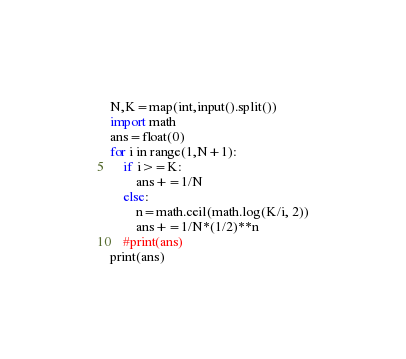Convert code to text. <code><loc_0><loc_0><loc_500><loc_500><_Python_>N,K=map(int,input().split())
import math
ans=float(0)
for i in range(1,N+1):
    if i>=K:
        ans+=1/N
    else:
        n=math.ceil(math.log(K/i, 2))
        ans+=1/N*(1/2)**n
    #print(ans)
print(ans)</code> 